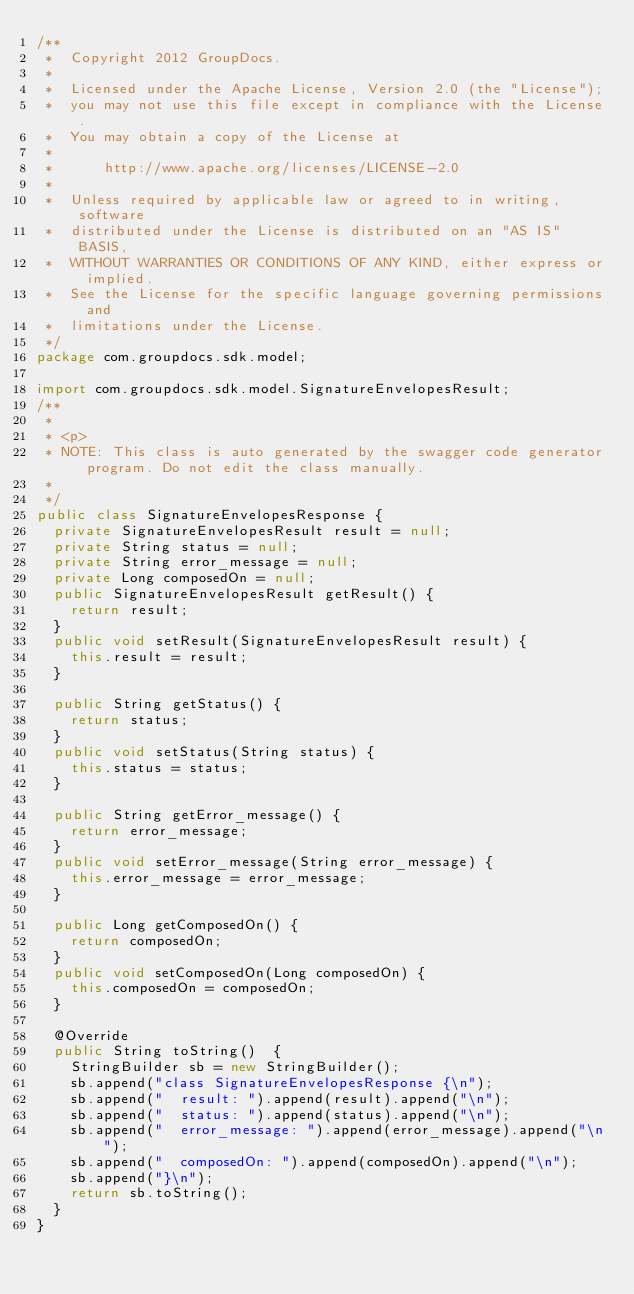Convert code to text. <code><loc_0><loc_0><loc_500><loc_500><_Java_>/**
 *  Copyright 2012 GroupDocs.
 *
 *  Licensed under the Apache License, Version 2.0 (the "License");
 *  you may not use this file except in compliance with the License.
 *  You may obtain a copy of the License at
 *
 *      http://www.apache.org/licenses/LICENSE-2.0
 *
 *  Unless required by applicable law or agreed to in writing, software
 *  distributed under the License is distributed on an "AS IS" BASIS,
 *  WITHOUT WARRANTIES OR CONDITIONS OF ANY KIND, either express or implied.
 *  See the License for the specific language governing permissions and
 *  limitations under the License.
 */
package com.groupdocs.sdk.model;

import com.groupdocs.sdk.model.SignatureEnvelopesResult;
/**
 * 
 * <p>
 * NOTE: This class is auto generated by the swagger code generator program. Do not edit the class manually.
 *
 */
public class SignatureEnvelopesResponse {
  private SignatureEnvelopesResult result = null;
  private String status = null;
  private String error_message = null;
  private Long composedOn = null;
  public SignatureEnvelopesResult getResult() {
    return result;
  }
  public void setResult(SignatureEnvelopesResult result) {
    this.result = result;
  }

  public String getStatus() {
    return status;
  }
  public void setStatus(String status) {
    this.status = status;
  }

  public String getError_message() {
    return error_message;
  }
  public void setError_message(String error_message) {
    this.error_message = error_message;
  }

  public Long getComposedOn() {
    return composedOn;
  }
  public void setComposedOn(Long composedOn) {
    this.composedOn = composedOn;
  }

  @Override
  public String toString()  {
    StringBuilder sb = new StringBuilder();
    sb.append("class SignatureEnvelopesResponse {\n");
    sb.append("  result: ").append(result).append("\n");
    sb.append("  status: ").append(status).append("\n");
    sb.append("  error_message: ").append(error_message).append("\n");
    sb.append("  composedOn: ").append(composedOn).append("\n");
    sb.append("}\n");
    return sb.toString();
  }
}

</code> 